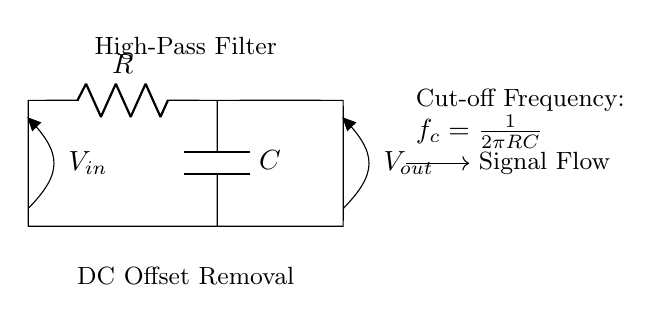What components are present in this high-pass filter circuit? The components in the circuit are a resistor and a capacitor. The resistor is labeled R, and the capacitor is labeled C in the diagram.
Answer: Resistor and capacitor What is the purpose of the capacitor in the high-pass filter? The capacitor allows AC signals to pass while blocking DC signals, thus removing the DC offset in the input signal.
Answer: Remove DC offset What is the cut-off frequency formula given in the circuit? The circuit provides the cut-off frequency formula as f_c = 1/(2πRC), which calculates the frequency at which the filter begins to attenuate lower frequencies.
Answer: f_c = 1/(2πRC) How does this circuit affect DC signals applied to the input? The high-pass filter will block DC signals from reaching the output, allowing only frequencies above the cut-off frequency to pass through.
Answer: Blocks DC signals What happens to signals below the cut-off frequency? Signals below the cut-off frequency are significantly attenuated and do not appear at the output, effectively being removed from the signal.
Answer: Attenuated What is measured at the output terminal of the circuit? The output terminal measures the processed AC signal, free from any DC offset from the input.
Answer: Processed AC signal 